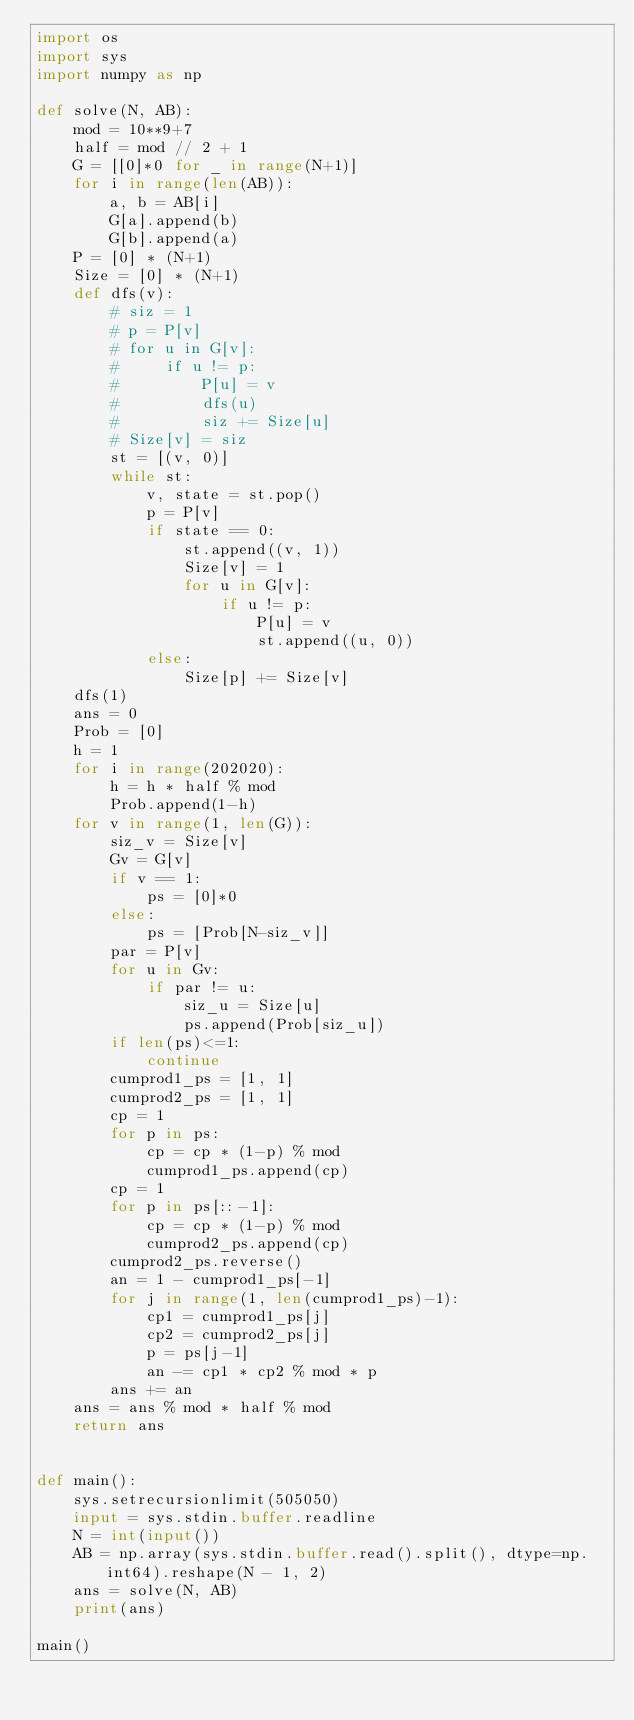<code> <loc_0><loc_0><loc_500><loc_500><_Python_>import os
import sys
import numpy as np

def solve(N, AB):
    mod = 10**9+7
    half = mod // 2 + 1
    G = [[0]*0 for _ in range(N+1)]
    for i in range(len(AB)):
        a, b = AB[i]
        G[a].append(b)
        G[b].append(a)
    P = [0] * (N+1)
    Size = [0] * (N+1)
    def dfs(v):
        # siz = 1
        # p = P[v]
        # for u in G[v]:
        #     if u != p:
        #         P[u] = v
        #         dfs(u)
        #         siz += Size[u]
        # Size[v] = siz
        st = [(v, 0)]
        while st:
            v, state = st.pop()
            p = P[v]
            if state == 0:
                st.append((v, 1))
                Size[v] = 1
                for u in G[v]:
                    if u != p:
                        P[u] = v
                        st.append((u, 0))
            else:
                Size[p] += Size[v]
    dfs(1)
    ans = 0
    Prob = [0]
    h = 1
    for i in range(202020):
        h = h * half % mod
        Prob.append(1-h)
    for v in range(1, len(G)):
        siz_v = Size[v]
        Gv = G[v]
        if v == 1:
            ps = [0]*0
        else:
            ps = [Prob[N-siz_v]]
        par = P[v]
        for u in Gv:
            if par != u:
                siz_u = Size[u]
                ps.append(Prob[siz_u])
        if len(ps)<=1:
            continue
        cumprod1_ps = [1, 1]
        cumprod2_ps = [1, 1]
        cp = 1
        for p in ps:
            cp = cp * (1-p) % mod
            cumprod1_ps.append(cp)
        cp = 1
        for p in ps[::-1]:
            cp = cp * (1-p) % mod
            cumprod2_ps.append(cp)
        cumprod2_ps.reverse()
        an = 1 - cumprod1_ps[-1]
        for j in range(1, len(cumprod1_ps)-1):
            cp1 = cumprod1_ps[j]
            cp2 = cumprod2_ps[j]
            p = ps[j-1]
            an -= cp1 * cp2 % mod * p
        ans += an
    ans = ans % mod * half % mod
    return ans


def main():
    sys.setrecursionlimit(505050)
    input = sys.stdin.buffer.readline
    N = int(input())
    AB = np.array(sys.stdin.buffer.read().split(), dtype=np.int64).reshape(N - 1, 2)
    ans = solve(N, AB)
    print(ans)

main()
</code> 